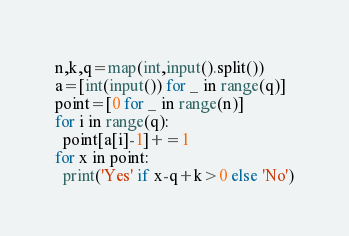Convert code to text. <code><loc_0><loc_0><loc_500><loc_500><_Python_>n,k,q=map(int,input().split())
a=[int(input()) for _ in range(q)]
point=[0 for _ in range(n)]
for i in range(q):
  point[a[i]-1]+=1
for x in point:
  print('Yes' if x-q+k>0 else 'No')
</code> 